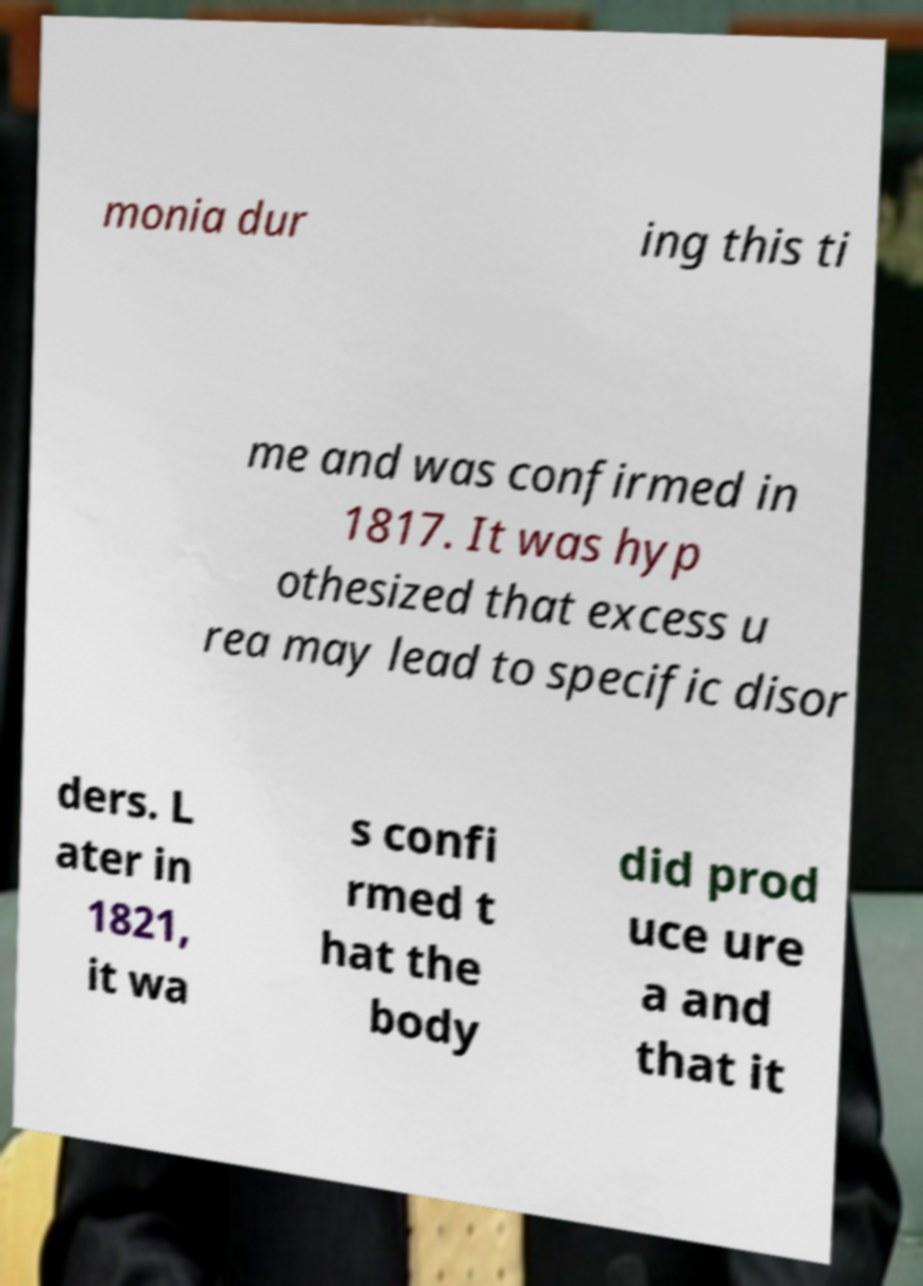What messages or text are displayed in this image? I need them in a readable, typed format. monia dur ing this ti me and was confirmed in 1817. It was hyp othesized that excess u rea may lead to specific disor ders. L ater in 1821, it wa s confi rmed t hat the body did prod uce ure a and that it 